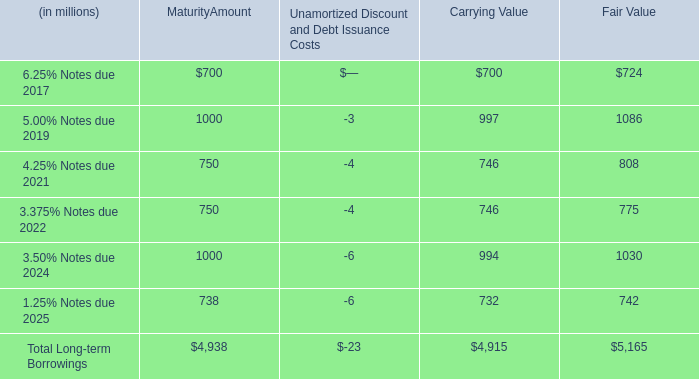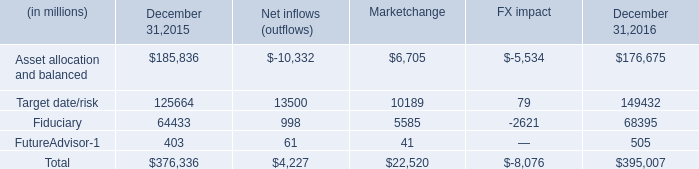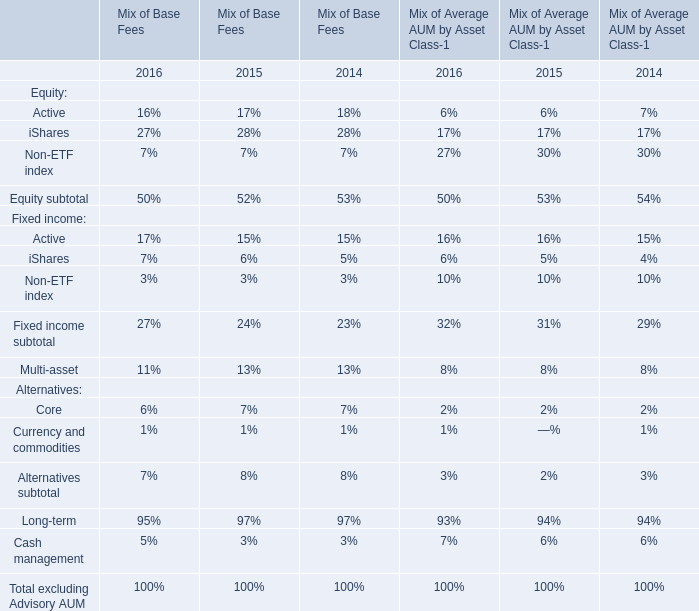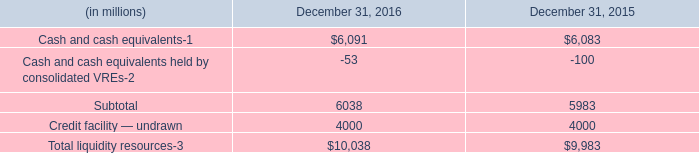what is the percentage change in total liquidity resources from 2015 to 2016? 
Computations: ((10038 - 9983) / 9983)
Answer: 0.00551. 